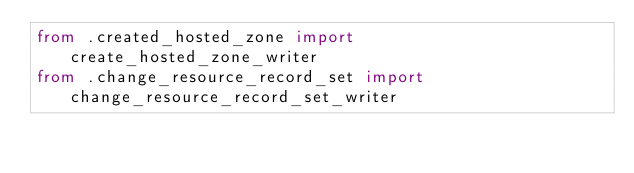Convert code to text. <code><loc_0><loc_0><loc_500><loc_500><_Python_>from .created_hosted_zone import create_hosted_zone_writer
from .change_resource_record_set import change_resource_record_set_writer</code> 